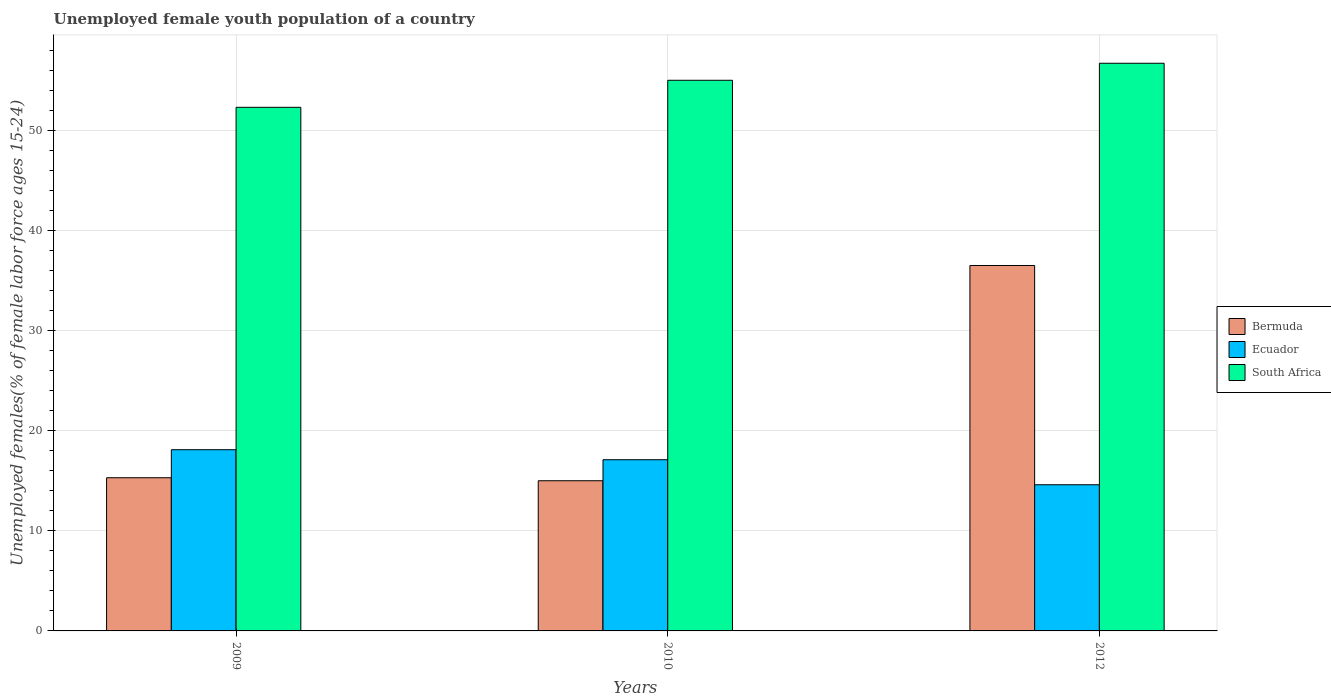How many groups of bars are there?
Provide a succinct answer. 3. Are the number of bars on each tick of the X-axis equal?
Give a very brief answer. Yes. How many bars are there on the 1st tick from the right?
Give a very brief answer. 3. What is the label of the 1st group of bars from the left?
Provide a short and direct response. 2009. In how many cases, is the number of bars for a given year not equal to the number of legend labels?
Your response must be concise. 0. What is the percentage of unemployed female youth population in South Africa in 2009?
Your answer should be very brief. 52.3. Across all years, what is the maximum percentage of unemployed female youth population in South Africa?
Offer a terse response. 56.7. Across all years, what is the minimum percentage of unemployed female youth population in Ecuador?
Your answer should be compact. 14.6. In which year was the percentage of unemployed female youth population in Bermuda maximum?
Ensure brevity in your answer.  2012. In which year was the percentage of unemployed female youth population in South Africa minimum?
Your answer should be compact. 2009. What is the total percentage of unemployed female youth population in Bermuda in the graph?
Your answer should be compact. 66.8. What is the difference between the percentage of unemployed female youth population in Bermuda in 2010 and that in 2012?
Give a very brief answer. -21.5. What is the average percentage of unemployed female youth population in Bermuda per year?
Keep it short and to the point. 22.27. In the year 2010, what is the difference between the percentage of unemployed female youth population in Bermuda and percentage of unemployed female youth population in Ecuador?
Your answer should be very brief. -2.1. In how many years, is the percentage of unemployed female youth population in Bermuda greater than 22 %?
Your answer should be very brief. 1. What is the ratio of the percentage of unemployed female youth population in Ecuador in 2010 to that in 2012?
Offer a very short reply. 1.17. Is the percentage of unemployed female youth population in Ecuador in 2010 less than that in 2012?
Offer a terse response. No. Is the difference between the percentage of unemployed female youth population in Bermuda in 2009 and 2010 greater than the difference between the percentage of unemployed female youth population in Ecuador in 2009 and 2010?
Provide a succinct answer. No. What is the difference between the highest and the second highest percentage of unemployed female youth population in Bermuda?
Your answer should be very brief. 21.2. What is the difference between the highest and the lowest percentage of unemployed female youth population in Bermuda?
Offer a terse response. 21.5. Is the sum of the percentage of unemployed female youth population in Bermuda in 2010 and 2012 greater than the maximum percentage of unemployed female youth population in South Africa across all years?
Your answer should be very brief. No. What does the 3rd bar from the left in 2012 represents?
Provide a succinct answer. South Africa. What does the 1st bar from the right in 2012 represents?
Provide a short and direct response. South Africa. How many bars are there?
Your response must be concise. 9. Are all the bars in the graph horizontal?
Your answer should be compact. No. How many years are there in the graph?
Make the answer very short. 3. Does the graph contain any zero values?
Provide a short and direct response. No. Does the graph contain grids?
Offer a terse response. Yes. How many legend labels are there?
Offer a very short reply. 3. What is the title of the graph?
Ensure brevity in your answer.  Unemployed female youth population of a country. Does "Trinidad and Tobago" appear as one of the legend labels in the graph?
Provide a short and direct response. No. What is the label or title of the Y-axis?
Your answer should be very brief. Unemployed females(% of female labor force ages 15-24). What is the Unemployed females(% of female labor force ages 15-24) in Bermuda in 2009?
Keep it short and to the point. 15.3. What is the Unemployed females(% of female labor force ages 15-24) of Ecuador in 2009?
Give a very brief answer. 18.1. What is the Unemployed females(% of female labor force ages 15-24) in South Africa in 2009?
Ensure brevity in your answer.  52.3. What is the Unemployed females(% of female labor force ages 15-24) in Bermuda in 2010?
Your answer should be very brief. 15. What is the Unemployed females(% of female labor force ages 15-24) in Ecuador in 2010?
Keep it short and to the point. 17.1. What is the Unemployed females(% of female labor force ages 15-24) of South Africa in 2010?
Ensure brevity in your answer.  55. What is the Unemployed females(% of female labor force ages 15-24) of Bermuda in 2012?
Your answer should be very brief. 36.5. What is the Unemployed females(% of female labor force ages 15-24) of Ecuador in 2012?
Provide a succinct answer. 14.6. What is the Unemployed females(% of female labor force ages 15-24) of South Africa in 2012?
Your answer should be compact. 56.7. Across all years, what is the maximum Unemployed females(% of female labor force ages 15-24) of Bermuda?
Offer a very short reply. 36.5. Across all years, what is the maximum Unemployed females(% of female labor force ages 15-24) of Ecuador?
Your answer should be very brief. 18.1. Across all years, what is the maximum Unemployed females(% of female labor force ages 15-24) of South Africa?
Give a very brief answer. 56.7. Across all years, what is the minimum Unemployed females(% of female labor force ages 15-24) in Ecuador?
Your answer should be very brief. 14.6. Across all years, what is the minimum Unemployed females(% of female labor force ages 15-24) in South Africa?
Keep it short and to the point. 52.3. What is the total Unemployed females(% of female labor force ages 15-24) in Bermuda in the graph?
Your response must be concise. 66.8. What is the total Unemployed females(% of female labor force ages 15-24) of Ecuador in the graph?
Offer a very short reply. 49.8. What is the total Unemployed females(% of female labor force ages 15-24) in South Africa in the graph?
Give a very brief answer. 164. What is the difference between the Unemployed females(% of female labor force ages 15-24) of Bermuda in 2009 and that in 2012?
Offer a terse response. -21.2. What is the difference between the Unemployed females(% of female labor force ages 15-24) of South Africa in 2009 and that in 2012?
Give a very brief answer. -4.4. What is the difference between the Unemployed females(% of female labor force ages 15-24) in Bermuda in 2010 and that in 2012?
Give a very brief answer. -21.5. What is the difference between the Unemployed females(% of female labor force ages 15-24) in Ecuador in 2010 and that in 2012?
Your response must be concise. 2.5. What is the difference between the Unemployed females(% of female labor force ages 15-24) of South Africa in 2010 and that in 2012?
Provide a short and direct response. -1.7. What is the difference between the Unemployed females(% of female labor force ages 15-24) of Bermuda in 2009 and the Unemployed females(% of female labor force ages 15-24) of Ecuador in 2010?
Offer a terse response. -1.8. What is the difference between the Unemployed females(% of female labor force ages 15-24) of Bermuda in 2009 and the Unemployed females(% of female labor force ages 15-24) of South Africa in 2010?
Give a very brief answer. -39.7. What is the difference between the Unemployed females(% of female labor force ages 15-24) of Ecuador in 2009 and the Unemployed females(% of female labor force ages 15-24) of South Africa in 2010?
Ensure brevity in your answer.  -36.9. What is the difference between the Unemployed females(% of female labor force ages 15-24) in Bermuda in 2009 and the Unemployed females(% of female labor force ages 15-24) in South Africa in 2012?
Your answer should be very brief. -41.4. What is the difference between the Unemployed females(% of female labor force ages 15-24) of Ecuador in 2009 and the Unemployed females(% of female labor force ages 15-24) of South Africa in 2012?
Make the answer very short. -38.6. What is the difference between the Unemployed females(% of female labor force ages 15-24) of Bermuda in 2010 and the Unemployed females(% of female labor force ages 15-24) of Ecuador in 2012?
Your response must be concise. 0.4. What is the difference between the Unemployed females(% of female labor force ages 15-24) in Bermuda in 2010 and the Unemployed females(% of female labor force ages 15-24) in South Africa in 2012?
Offer a terse response. -41.7. What is the difference between the Unemployed females(% of female labor force ages 15-24) in Ecuador in 2010 and the Unemployed females(% of female labor force ages 15-24) in South Africa in 2012?
Your answer should be compact. -39.6. What is the average Unemployed females(% of female labor force ages 15-24) in Bermuda per year?
Offer a very short reply. 22.27. What is the average Unemployed females(% of female labor force ages 15-24) in Ecuador per year?
Provide a succinct answer. 16.6. What is the average Unemployed females(% of female labor force ages 15-24) in South Africa per year?
Make the answer very short. 54.67. In the year 2009, what is the difference between the Unemployed females(% of female labor force ages 15-24) of Bermuda and Unemployed females(% of female labor force ages 15-24) of South Africa?
Provide a succinct answer. -37. In the year 2009, what is the difference between the Unemployed females(% of female labor force ages 15-24) of Ecuador and Unemployed females(% of female labor force ages 15-24) of South Africa?
Your response must be concise. -34.2. In the year 2010, what is the difference between the Unemployed females(% of female labor force ages 15-24) in Bermuda and Unemployed females(% of female labor force ages 15-24) in Ecuador?
Your answer should be compact. -2.1. In the year 2010, what is the difference between the Unemployed females(% of female labor force ages 15-24) of Ecuador and Unemployed females(% of female labor force ages 15-24) of South Africa?
Your response must be concise. -37.9. In the year 2012, what is the difference between the Unemployed females(% of female labor force ages 15-24) of Bermuda and Unemployed females(% of female labor force ages 15-24) of Ecuador?
Ensure brevity in your answer.  21.9. In the year 2012, what is the difference between the Unemployed females(% of female labor force ages 15-24) of Bermuda and Unemployed females(% of female labor force ages 15-24) of South Africa?
Ensure brevity in your answer.  -20.2. In the year 2012, what is the difference between the Unemployed females(% of female labor force ages 15-24) in Ecuador and Unemployed females(% of female labor force ages 15-24) in South Africa?
Offer a terse response. -42.1. What is the ratio of the Unemployed females(% of female labor force ages 15-24) in Bermuda in 2009 to that in 2010?
Offer a terse response. 1.02. What is the ratio of the Unemployed females(% of female labor force ages 15-24) of Ecuador in 2009 to that in 2010?
Offer a very short reply. 1.06. What is the ratio of the Unemployed females(% of female labor force ages 15-24) in South Africa in 2009 to that in 2010?
Offer a very short reply. 0.95. What is the ratio of the Unemployed females(% of female labor force ages 15-24) in Bermuda in 2009 to that in 2012?
Your response must be concise. 0.42. What is the ratio of the Unemployed females(% of female labor force ages 15-24) in Ecuador in 2009 to that in 2012?
Offer a very short reply. 1.24. What is the ratio of the Unemployed females(% of female labor force ages 15-24) in South Africa in 2009 to that in 2012?
Give a very brief answer. 0.92. What is the ratio of the Unemployed females(% of female labor force ages 15-24) in Bermuda in 2010 to that in 2012?
Make the answer very short. 0.41. What is the ratio of the Unemployed females(% of female labor force ages 15-24) of Ecuador in 2010 to that in 2012?
Give a very brief answer. 1.17. What is the ratio of the Unemployed females(% of female labor force ages 15-24) in South Africa in 2010 to that in 2012?
Make the answer very short. 0.97. What is the difference between the highest and the second highest Unemployed females(% of female labor force ages 15-24) in Bermuda?
Provide a short and direct response. 21.2. What is the difference between the highest and the second highest Unemployed females(% of female labor force ages 15-24) of South Africa?
Provide a short and direct response. 1.7. What is the difference between the highest and the lowest Unemployed females(% of female labor force ages 15-24) of South Africa?
Ensure brevity in your answer.  4.4. 